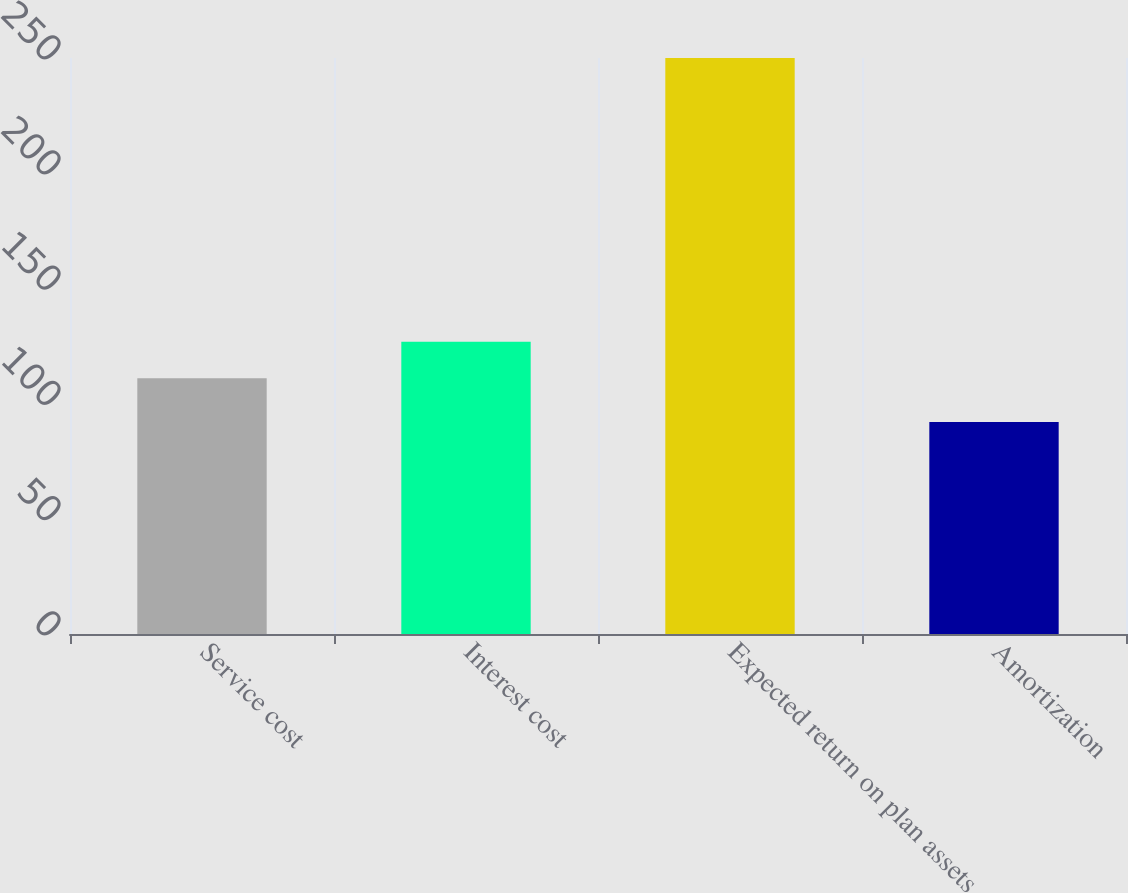Convert chart to OTSL. <chart><loc_0><loc_0><loc_500><loc_500><bar_chart><fcel>Service cost<fcel>Interest cost<fcel>Expected return on plan assets<fcel>Amortization<nl><fcel>111<fcel>126.8<fcel>250<fcel>92<nl></chart> 